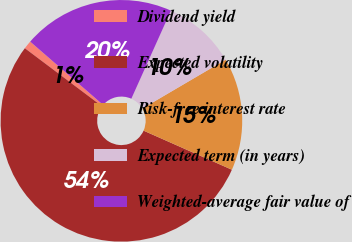Convert chart. <chart><loc_0><loc_0><loc_500><loc_500><pie_chart><fcel>Dividend yield<fcel>Expected volatility<fcel>Risk-free interest rate<fcel>Expected term (in years)<fcel>Weighted-average fair value of<nl><fcel>1.12%<fcel>53.63%<fcel>15.08%<fcel>9.83%<fcel>20.34%<nl></chart> 